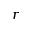Convert formula to latex. <formula><loc_0><loc_0><loc_500><loc_500>r</formula> 